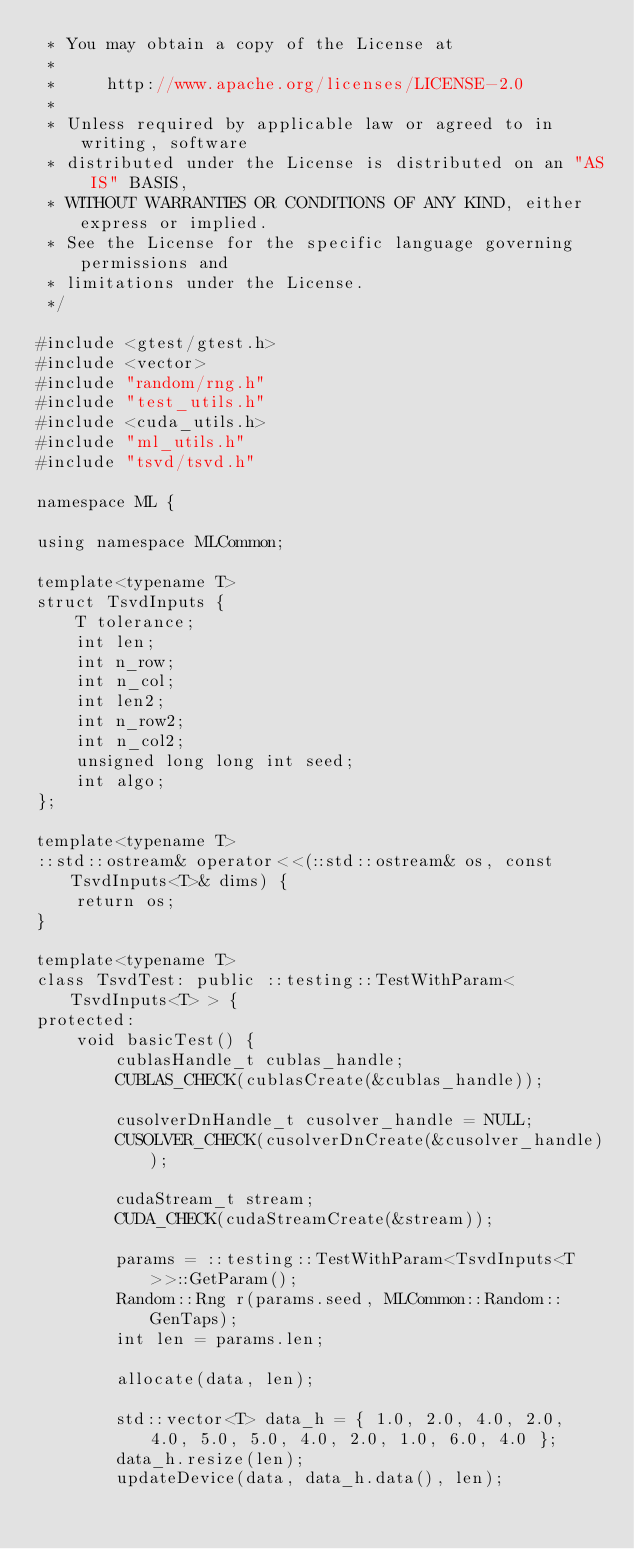<code> <loc_0><loc_0><loc_500><loc_500><_Cuda_> * You may obtain a copy of the License at
 *
 *     http://www.apache.org/licenses/LICENSE-2.0
 *
 * Unless required by applicable law or agreed to in writing, software
 * distributed under the License is distributed on an "AS IS" BASIS,
 * WITHOUT WARRANTIES OR CONDITIONS OF ANY KIND, either express or implied.
 * See the License for the specific language governing permissions and
 * limitations under the License.
 */

#include <gtest/gtest.h>
#include <vector>
#include "random/rng.h"
#include "test_utils.h"
#include <cuda_utils.h>
#include "ml_utils.h"
#include "tsvd/tsvd.h"

namespace ML {

using namespace MLCommon;

template<typename T>
struct TsvdInputs {
	T tolerance;
	int len;
	int n_row;
	int n_col;
	int len2;
	int n_row2;
	int n_col2;
	unsigned long long int seed;
	int algo;
};

template<typename T>
::std::ostream& operator<<(::std::ostream& os, const TsvdInputs<T>& dims) {
	return os;
}

template<typename T>
class TsvdTest: public ::testing::TestWithParam<TsvdInputs<T> > {
protected:
	void basicTest() {
		cublasHandle_t cublas_handle;
		CUBLAS_CHECK(cublasCreate(&cublas_handle));

		cusolverDnHandle_t cusolver_handle = NULL;
		CUSOLVER_CHECK(cusolverDnCreate(&cusolver_handle));

		cudaStream_t stream;
		CUDA_CHECK(cudaStreamCreate(&stream));

		params = ::testing::TestWithParam<TsvdInputs<T>>::GetParam();
		Random::Rng r(params.seed, MLCommon::Random::GenTaps);
		int len = params.len;

		allocate(data, len);

		std::vector<T> data_h = { 1.0, 2.0, 4.0, 2.0, 4.0, 5.0, 5.0, 4.0, 2.0, 1.0, 6.0, 4.0 };
		data_h.resize(len);
		updateDevice(data, data_h.data(), len);
</code> 